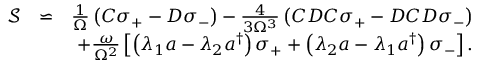<formula> <loc_0><loc_0><loc_500><loc_500>\begin{array} { r l r } { \mathcal { S } } & { \backsimeq } & { \frac { 1 } { \Omega } \left ( C \sigma _ { + } - D \sigma _ { - } \right ) - \frac { 4 } { 3 \Omega ^ { 3 } } \left ( C D C \sigma _ { + } - D C D \sigma _ { - } \right ) } \\ & { + \frac { \omega } { \Omega ^ { 2 } } \left [ \left ( \lambda _ { 1 } a - \lambda _ { 2 } a ^ { \dagger } \right ) \sigma _ { + } + \left ( \lambda _ { 2 } a - \lambda _ { 1 } a ^ { \dagger } \right ) \sigma _ { - } \right ] . } \end{array}</formula> 